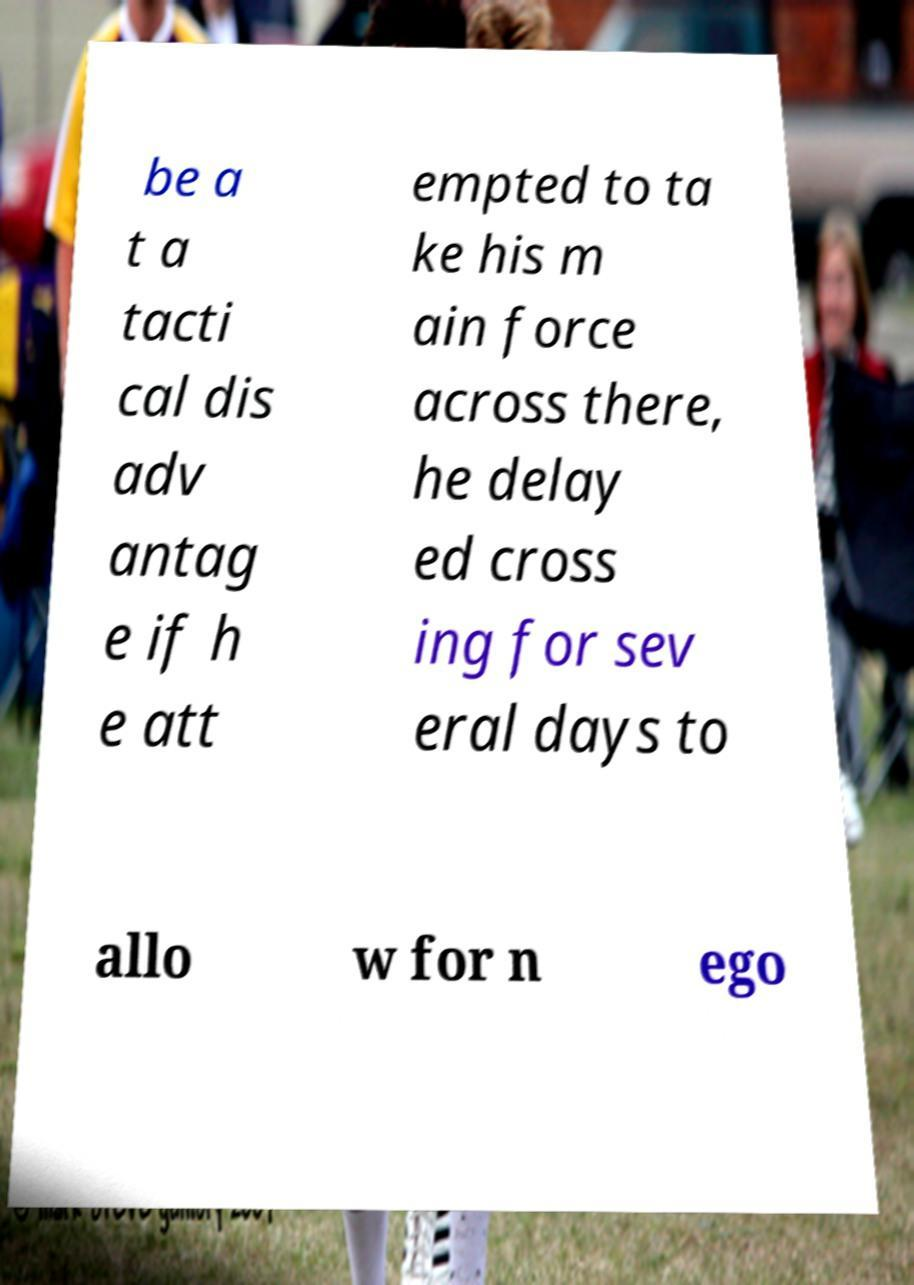Could you extract and type out the text from this image? be a t a tacti cal dis adv antag e if h e att empted to ta ke his m ain force across there, he delay ed cross ing for sev eral days to allo w for n ego 